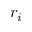<formula> <loc_0><loc_0><loc_500><loc_500>r _ { i }</formula> 